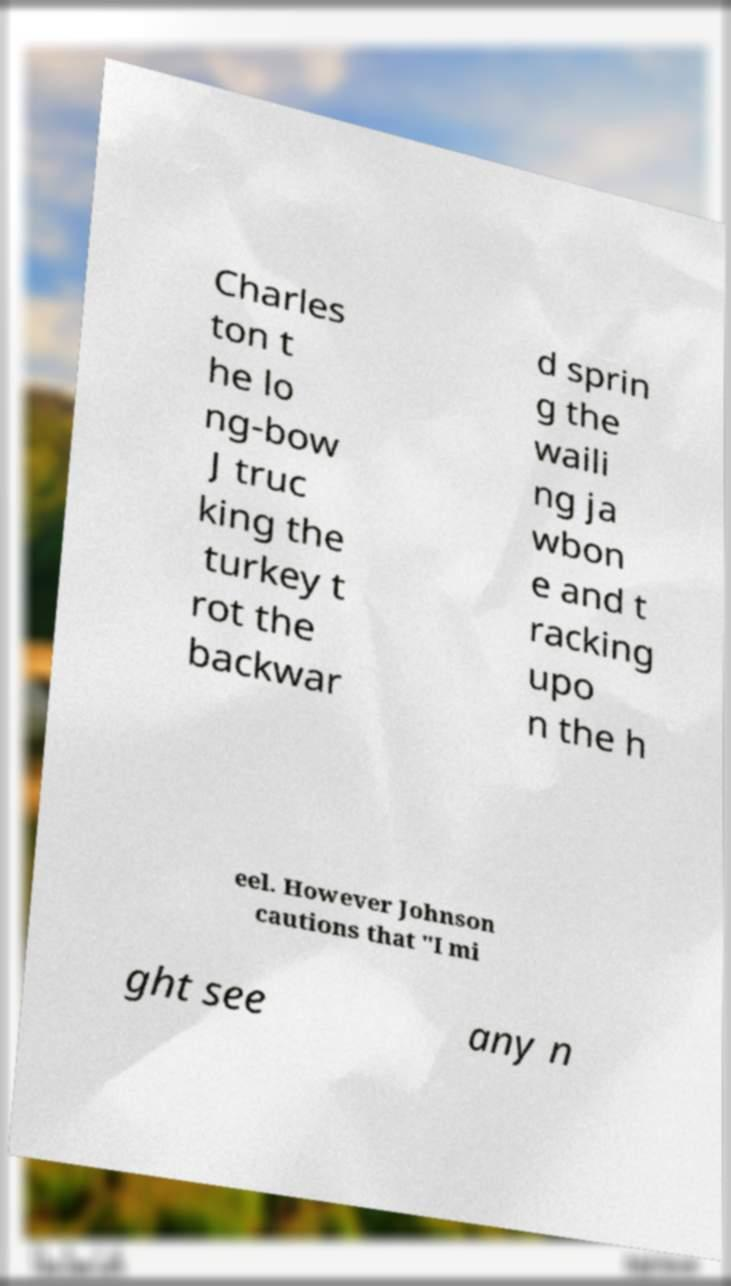Please identify and transcribe the text found in this image. Charles ton t he lo ng-bow J truc king the turkey t rot the backwar d sprin g the waili ng ja wbon e and t racking upo n the h eel. However Johnson cautions that "I mi ght see any n 